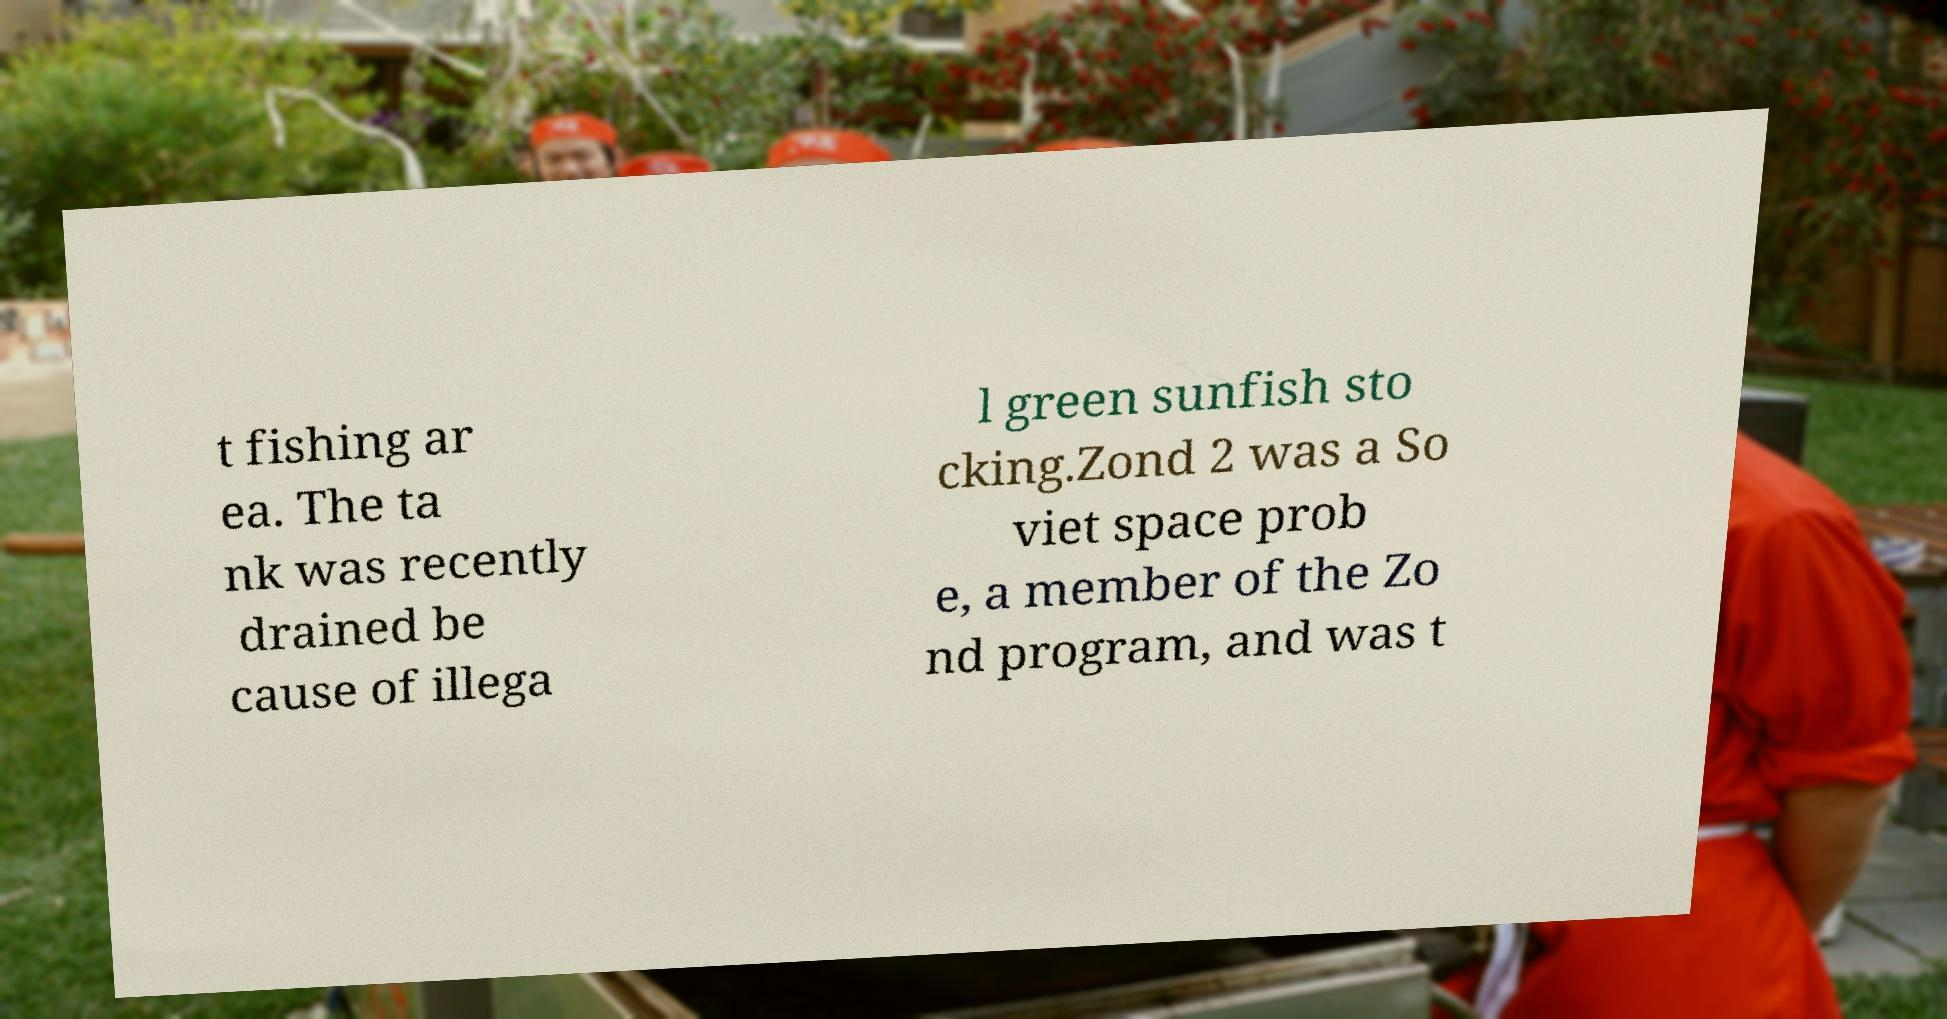Please read and relay the text visible in this image. What does it say? t fishing ar ea. The ta nk was recently drained be cause of illega l green sunfish sto cking.Zond 2 was a So viet space prob e, a member of the Zo nd program, and was t 